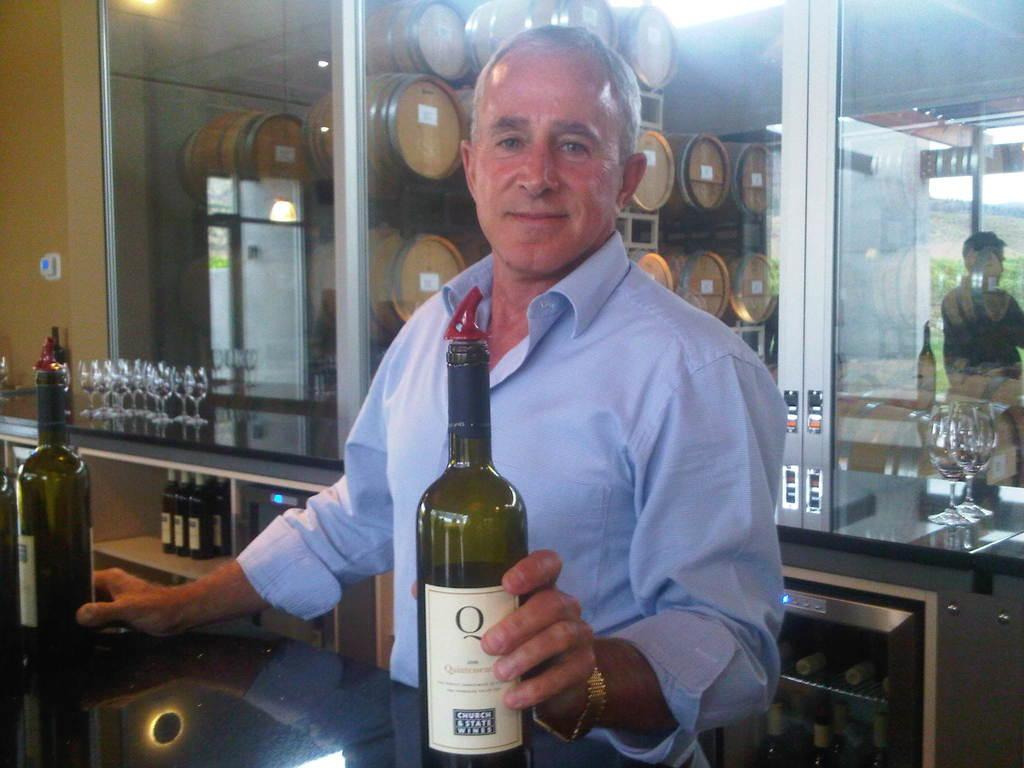<image>
Create a compact narrative representing the image presented. A man holds a bottle with the words church and state wines on the bottom of the label. 